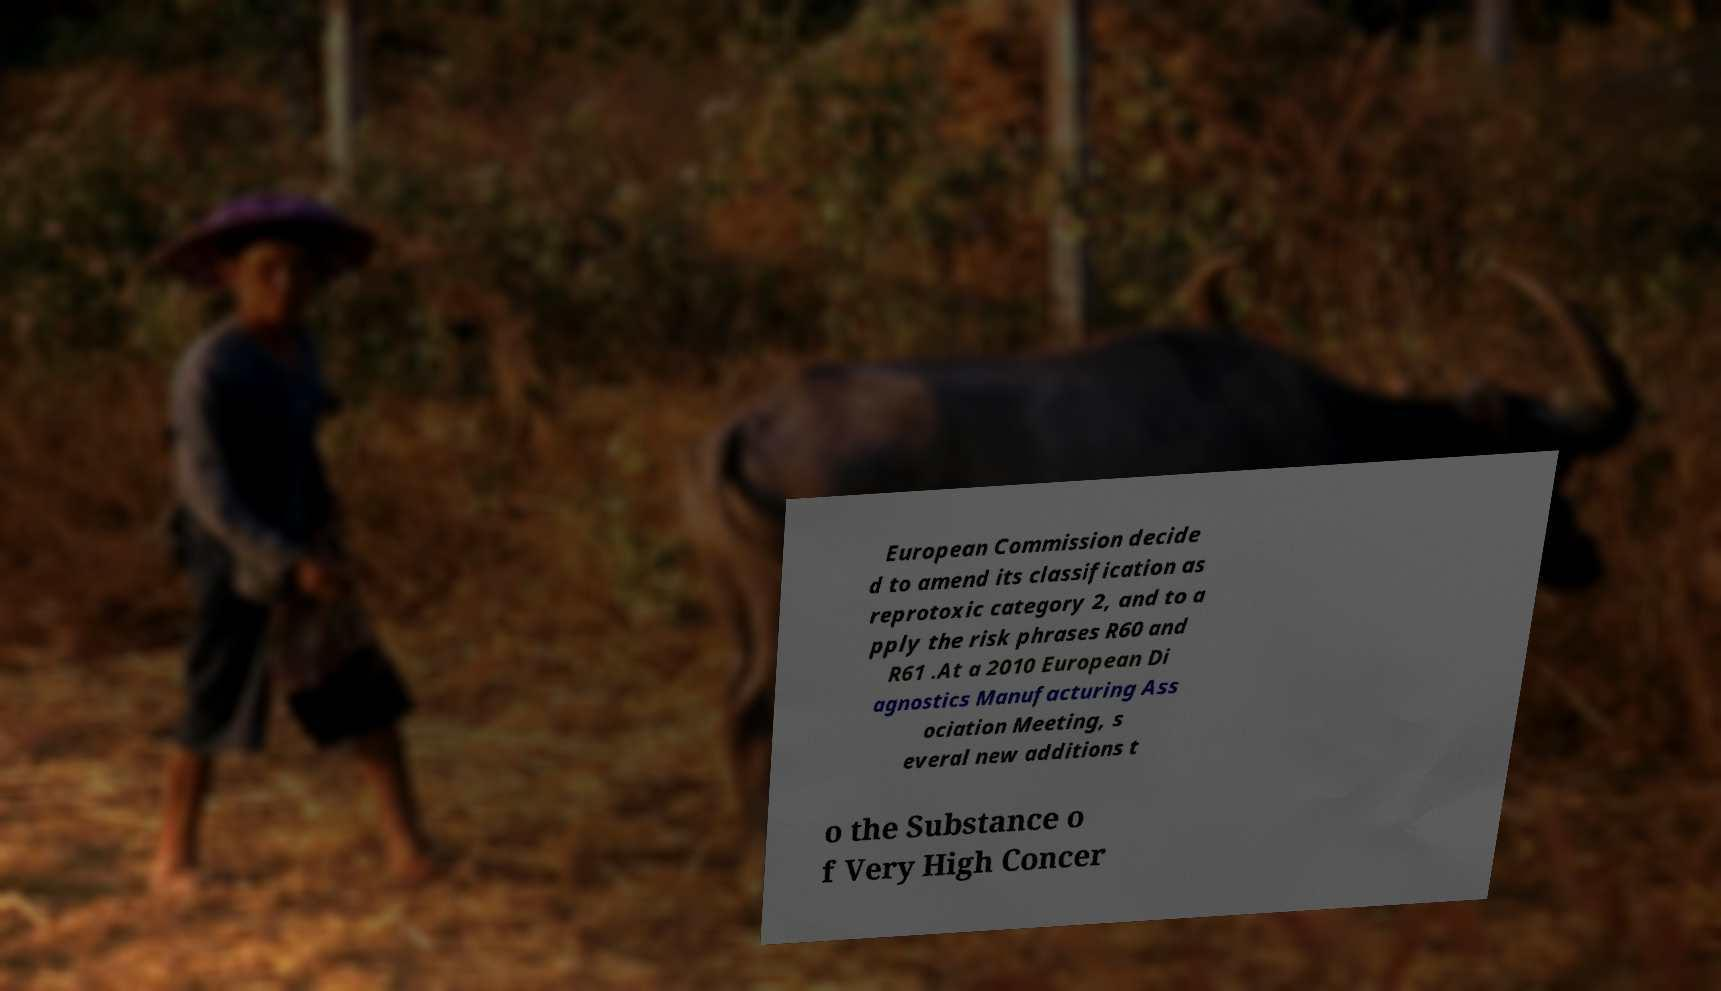What messages or text are displayed in this image? I need them in a readable, typed format. European Commission decide d to amend its classification as reprotoxic category 2, and to a pply the risk phrases R60 and R61 .At a 2010 European Di agnostics Manufacturing Ass ociation Meeting, s everal new additions t o the Substance o f Very High Concer 